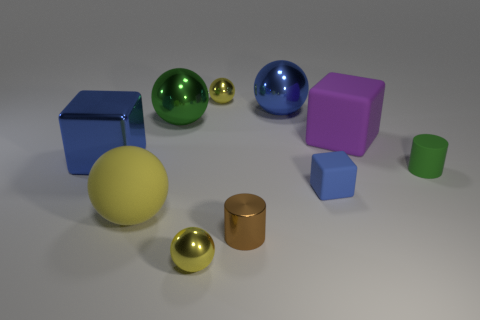Subtract all cyan cylinders. How many yellow spheres are left? 3 Subtract all green spheres. How many spheres are left? 4 Subtract all large green metallic spheres. How many spheres are left? 4 Subtract all red balls. Subtract all green cylinders. How many balls are left? 5 Subtract all cubes. How many objects are left? 7 Add 3 yellow shiny balls. How many yellow shiny balls are left? 5 Add 2 brown metal balls. How many brown metal balls exist? 2 Subtract 1 blue balls. How many objects are left? 9 Subtract all big purple objects. Subtract all tiny green rubber things. How many objects are left? 8 